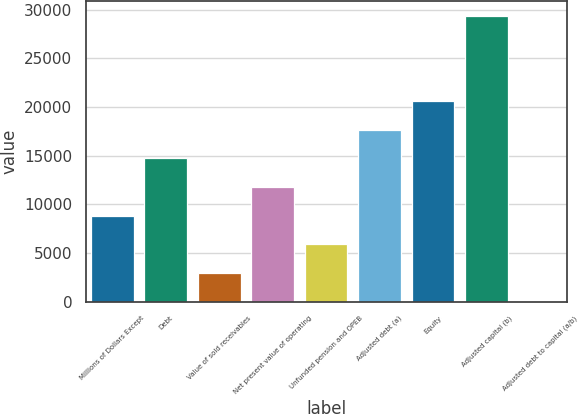<chart> <loc_0><loc_0><loc_500><loc_500><bar_chart><fcel>Millions of Dollars Except<fcel>Debt<fcel>Value of sold receivables<fcel>Net present value of operating<fcel>Unfunded pension and OPEB<fcel>Adjusted debt (a)<fcel>Equity<fcel>Adjusted capital (b)<fcel>Adjusted debt to capital (a/b)<nl><fcel>8847.48<fcel>14714.2<fcel>2980.76<fcel>11780.8<fcel>5914.12<fcel>17647.6<fcel>20580.9<fcel>29381<fcel>47.4<nl></chart> 